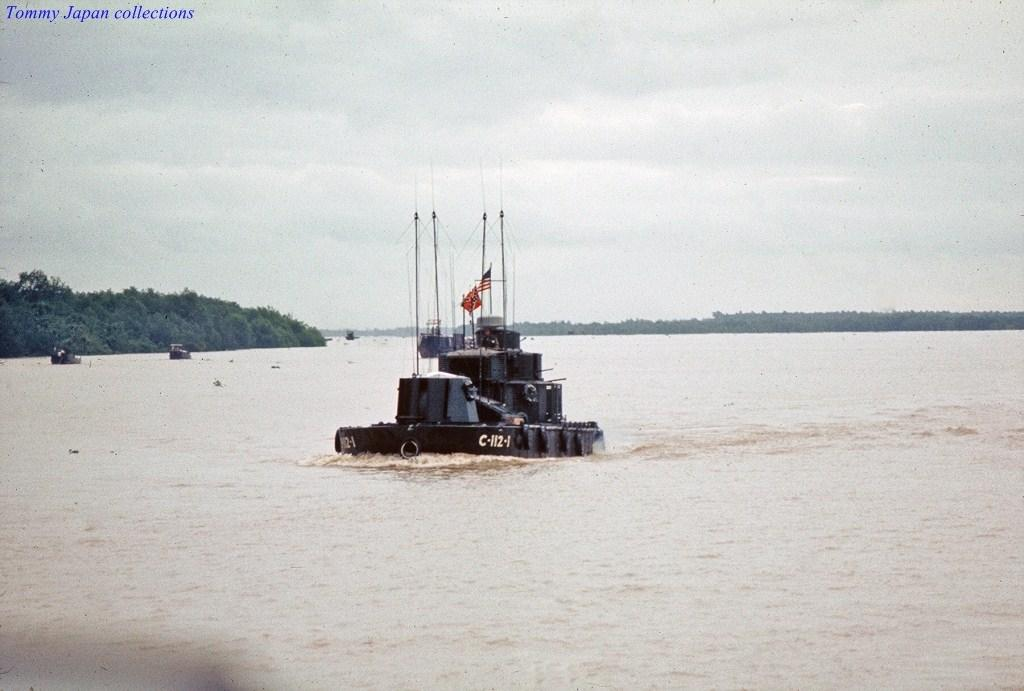Provide a one-sentence caption for the provided image. A picture in the Tommy Japan collections depicting the US submarine C-112-4. 